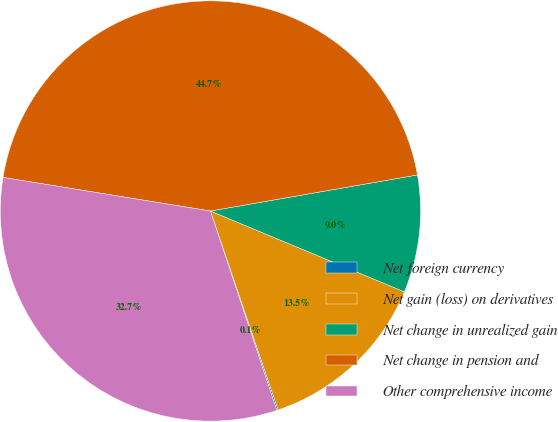Convert chart. <chart><loc_0><loc_0><loc_500><loc_500><pie_chart><fcel>Net foreign currency<fcel>Net gain (loss) on derivatives<fcel>Net change in unrealized gain<fcel>Net change in pension and<fcel>Other comprehensive income<nl><fcel>0.11%<fcel>13.49%<fcel>9.03%<fcel>44.7%<fcel>32.67%<nl></chart> 